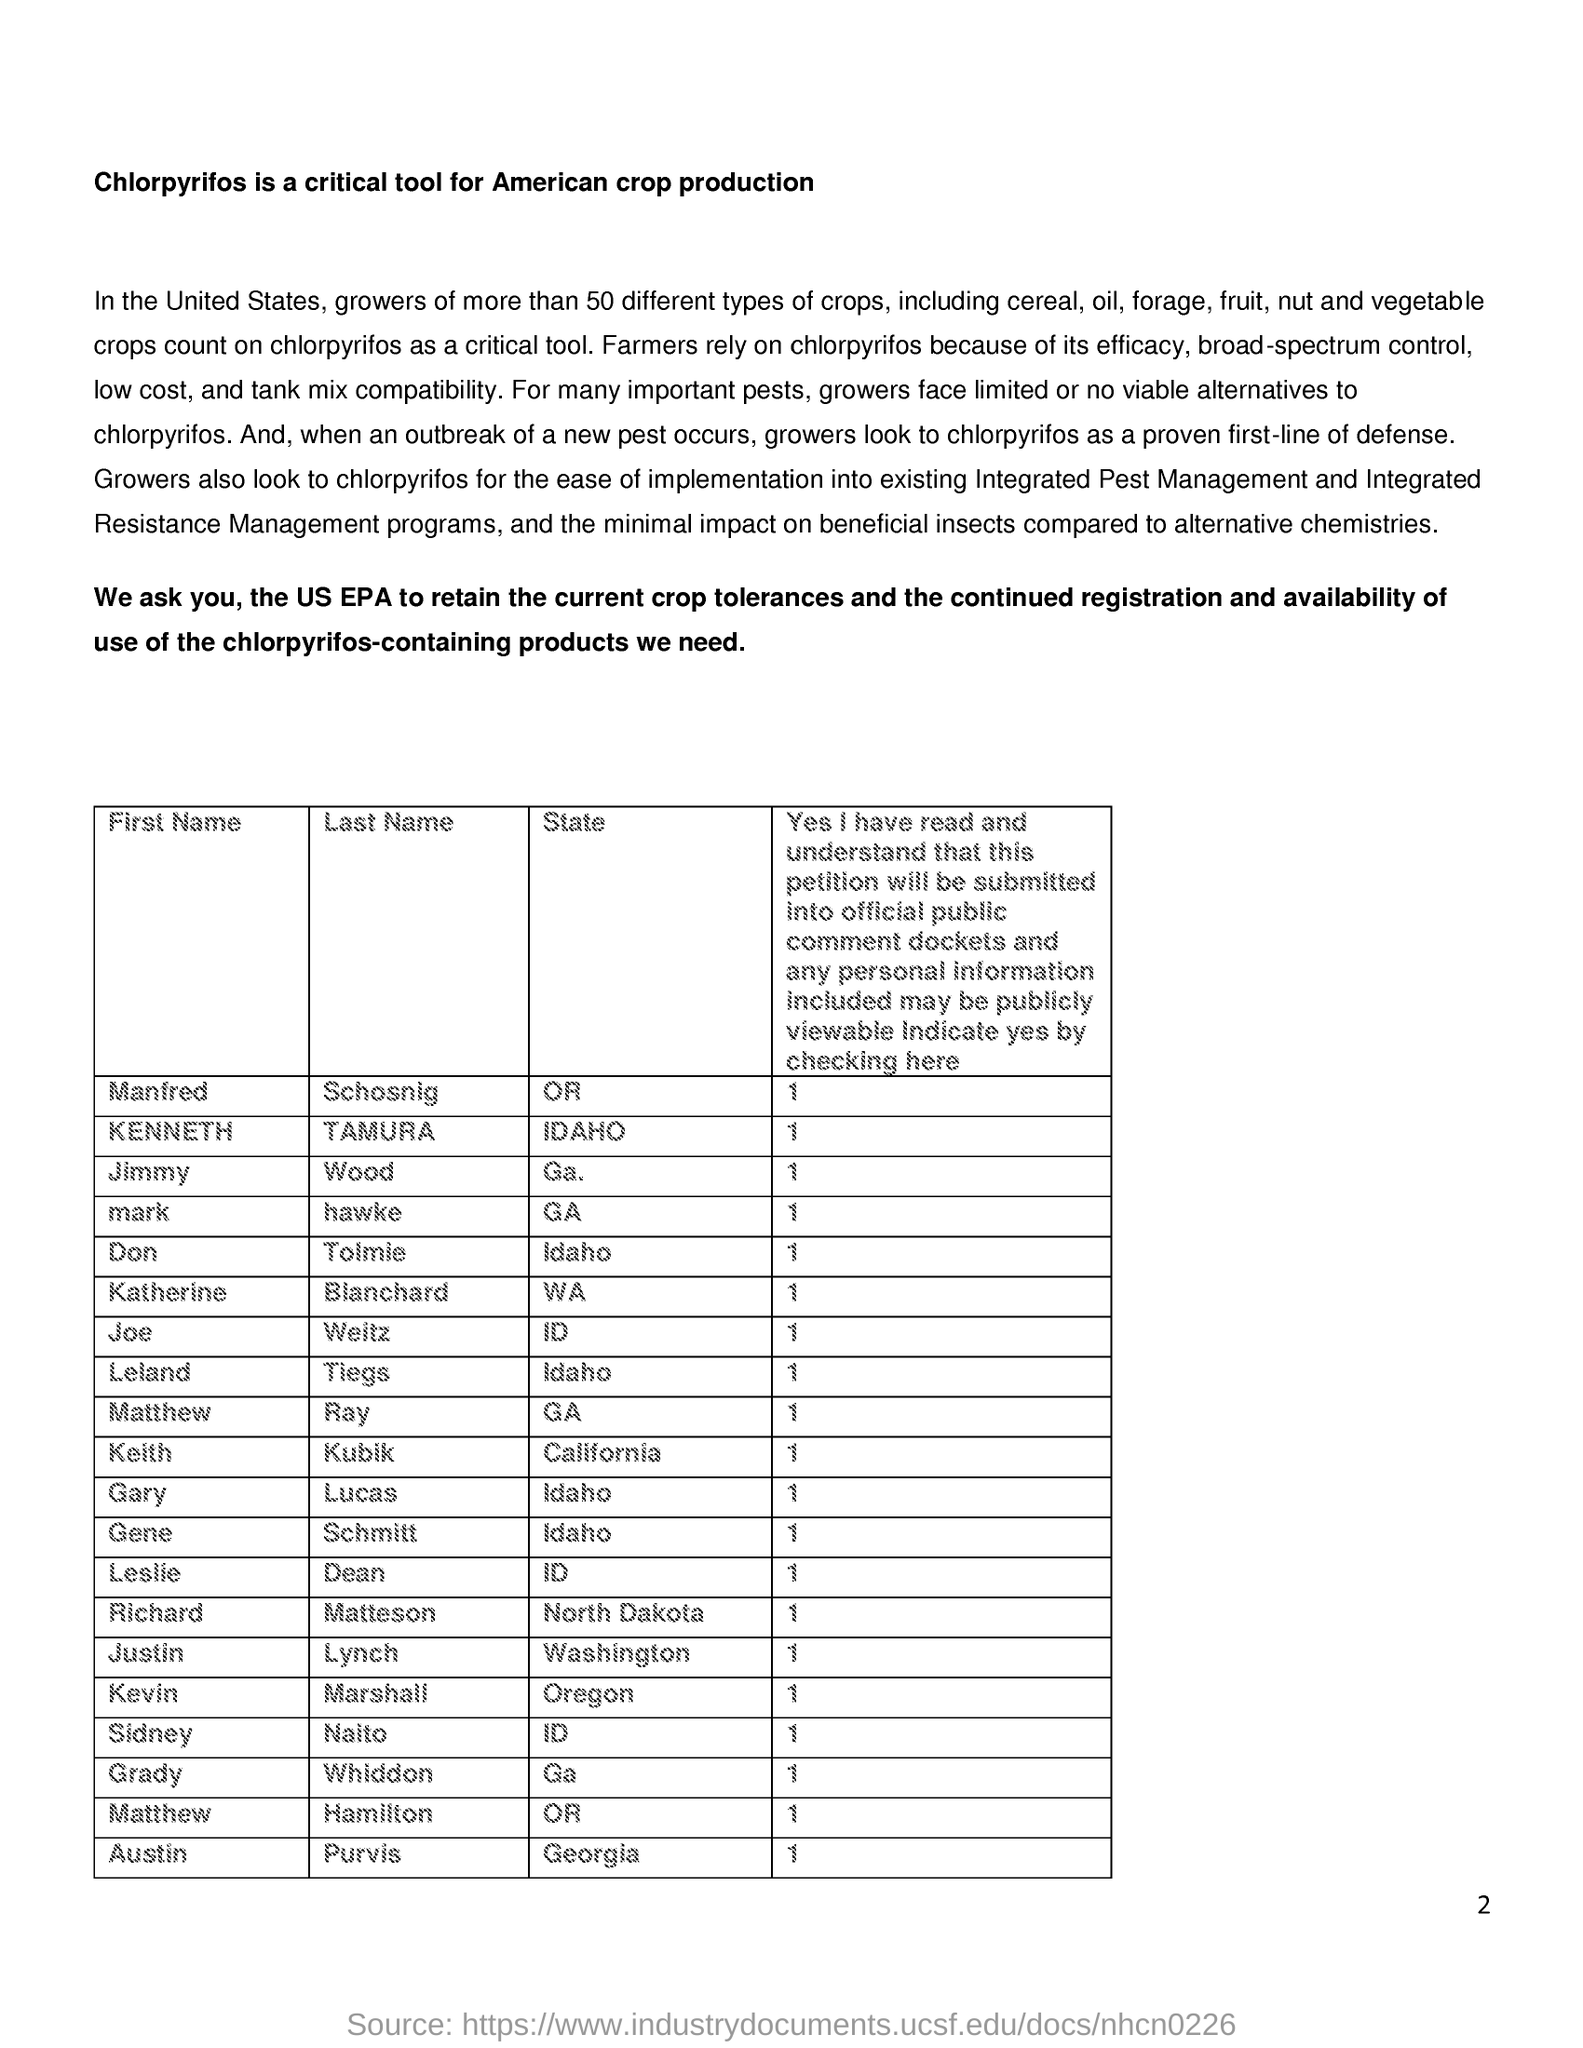What is the critical tool used for American Crop production?
Offer a terse response. Chlorpyrifos. Why do farmers rely on Chlorpyrifos?
Provide a short and direct response. Because of its efficacy, broad spectrum control, low cost, and tank mix compatibility. When a outbreak of a new pest occurs, what do growers look to?
Offer a terse response. Chlorpyrifos as a proven first-line of defense. Which state of United States does Justiin Lynch belongs to?
Ensure brevity in your answer.  Washington. 